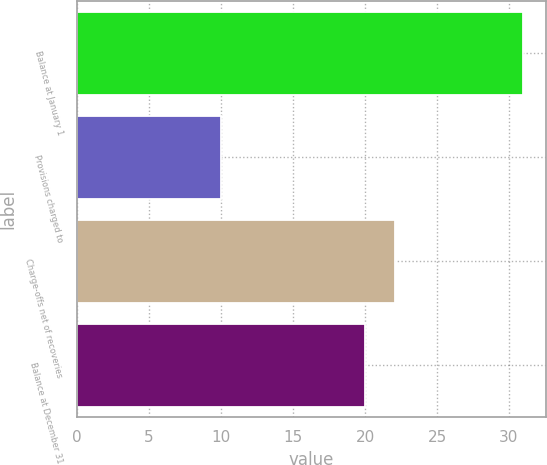<chart> <loc_0><loc_0><loc_500><loc_500><bar_chart><fcel>Balance at January 1<fcel>Provisions charged to<fcel>Charge-offs net of recoveries<fcel>Balance at December 31<nl><fcel>31<fcel>10<fcel>22.1<fcel>20<nl></chart> 